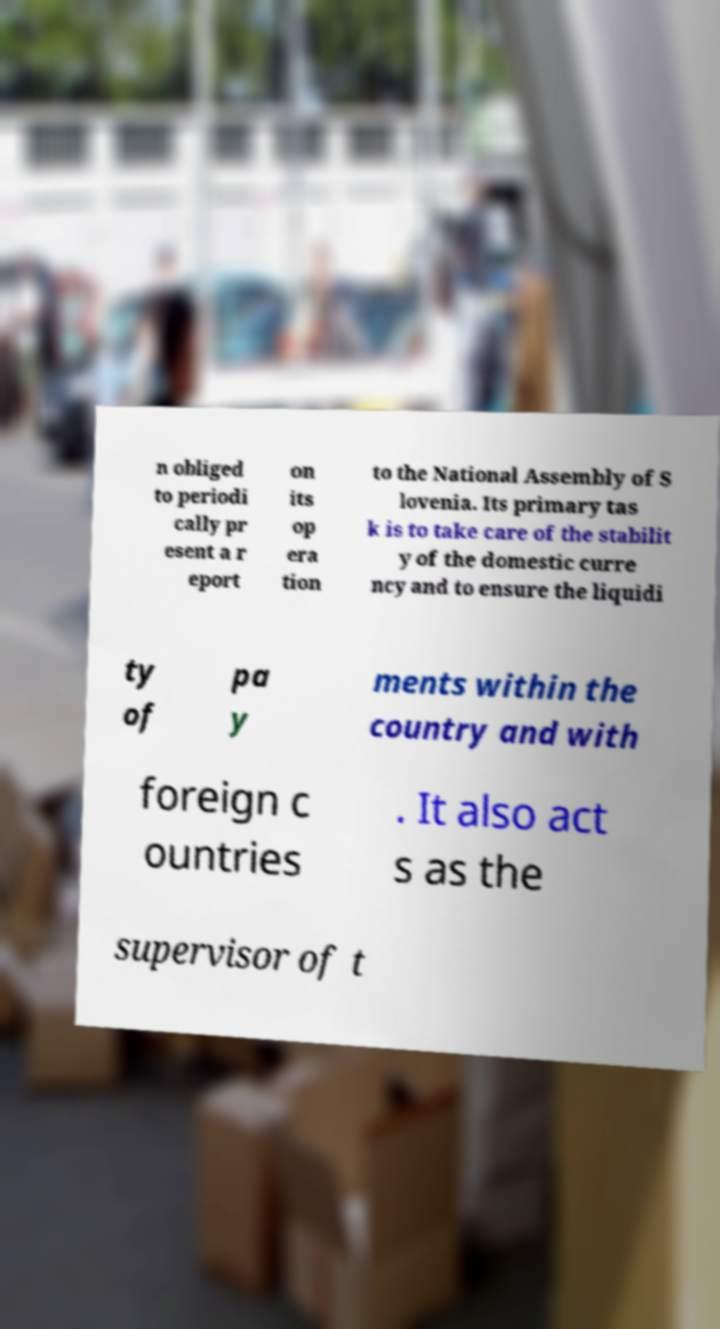Could you assist in decoding the text presented in this image and type it out clearly? n obliged to periodi cally pr esent a r eport on its op era tion to the National Assembly of S lovenia. Its primary tas k is to take care of the stabilit y of the domestic curre ncy and to ensure the liquidi ty of pa y ments within the country and with foreign c ountries . It also act s as the supervisor of t 